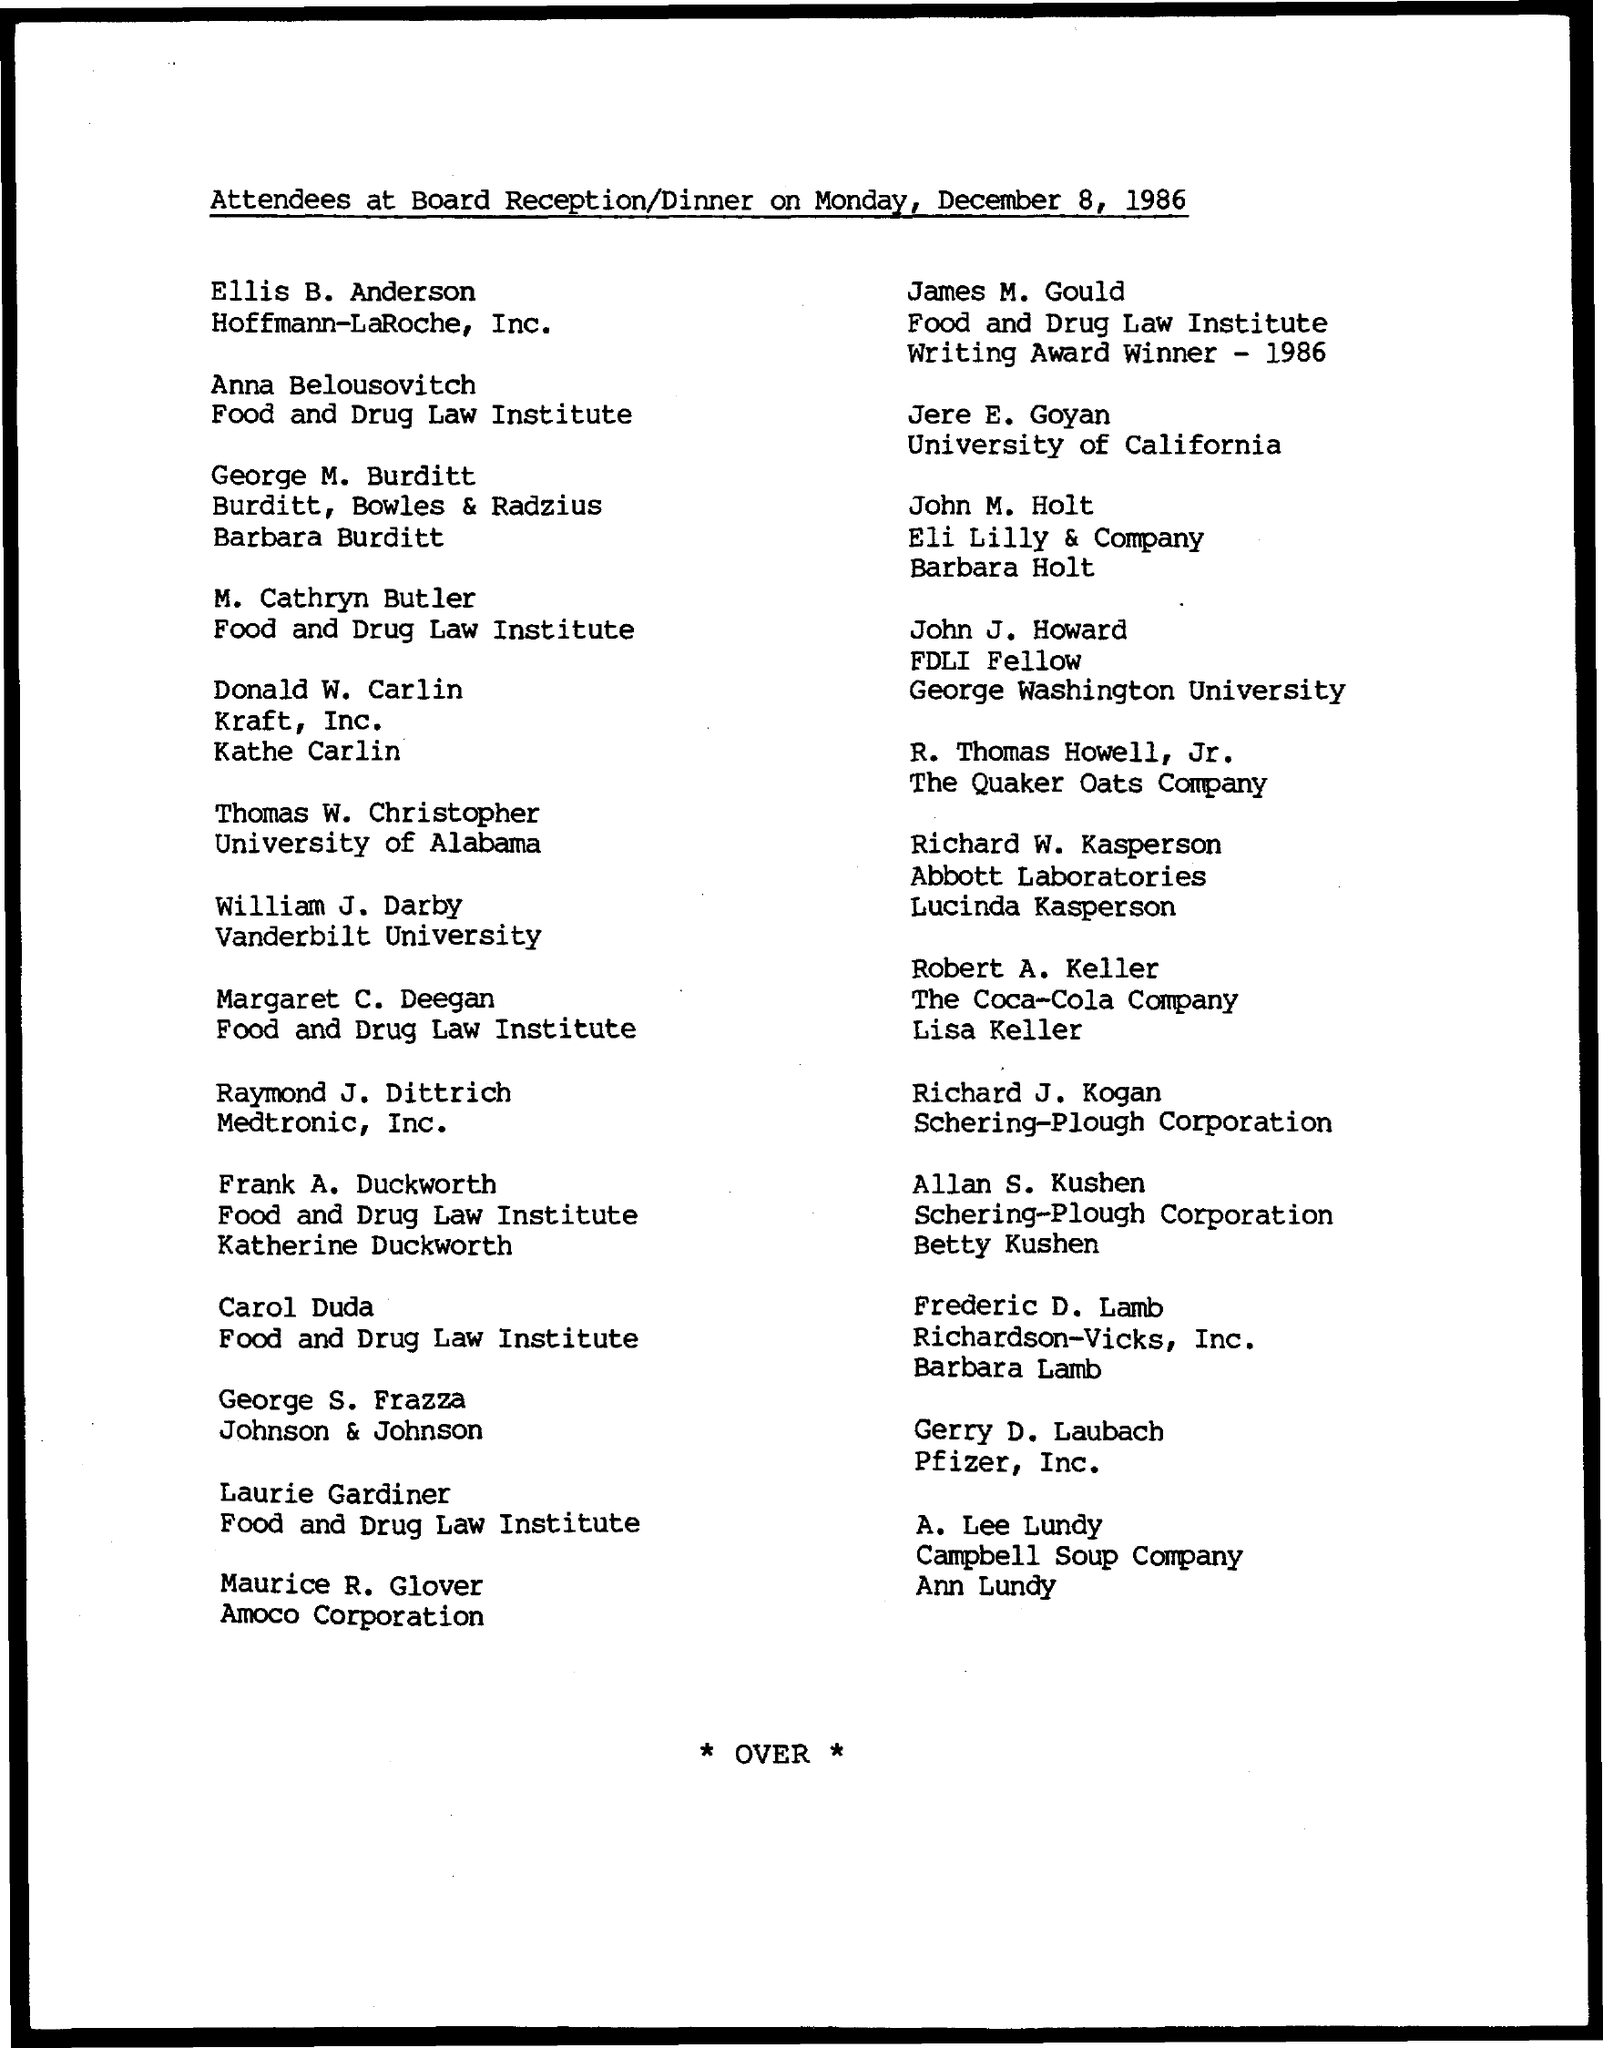When is the Board Receipt/Dinner?
Ensure brevity in your answer.  Monday, December 8, 1986. Where is Jere E. Goyan from?
Make the answer very short. University of California. 